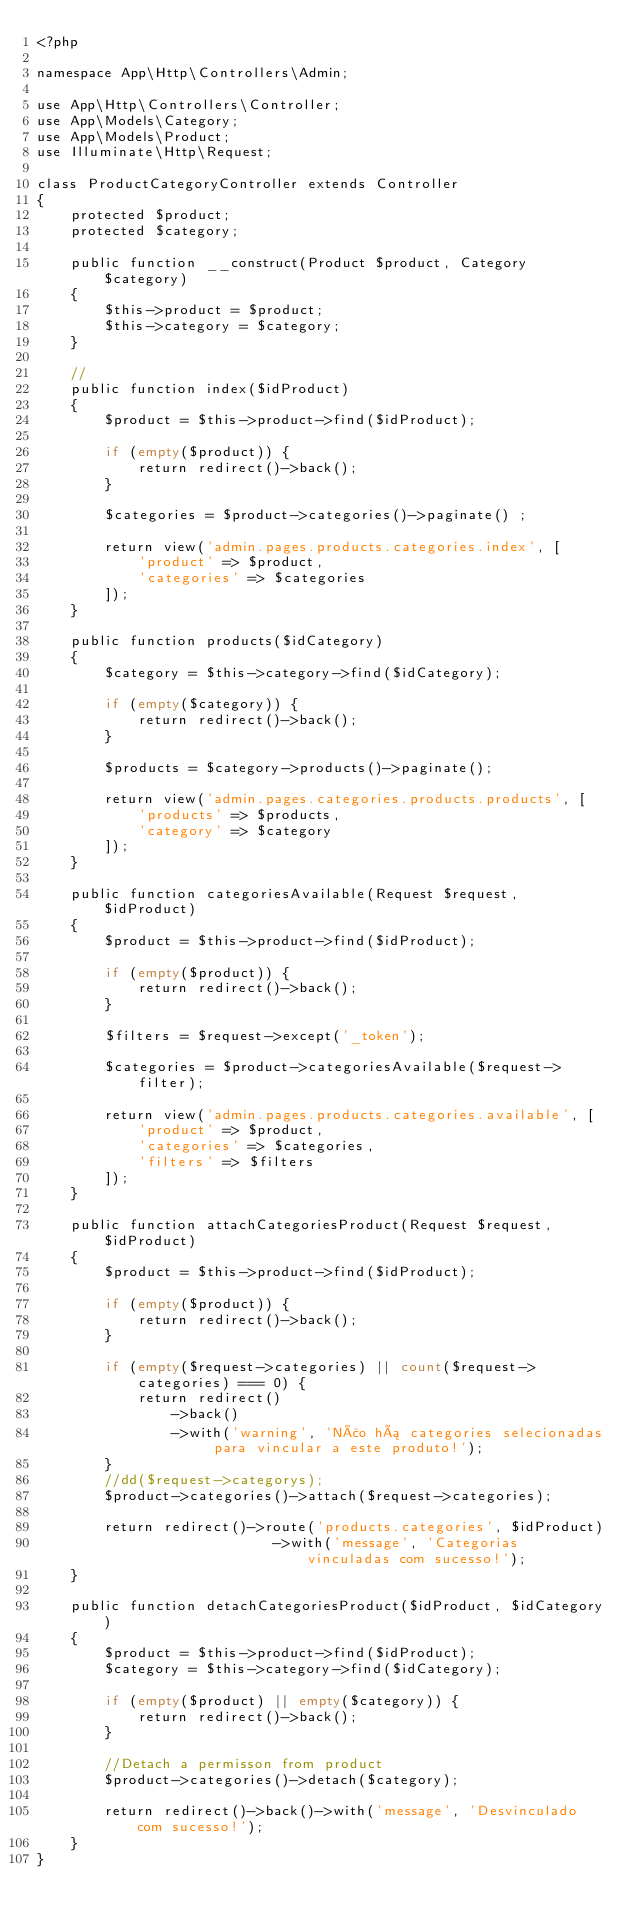<code> <loc_0><loc_0><loc_500><loc_500><_PHP_><?php

namespace App\Http\Controllers\Admin;

use App\Http\Controllers\Controller;
use App\Models\Category;
use App\Models\Product;
use Illuminate\Http\Request;

class ProductCategoryController extends Controller
{
    protected $product;
    protected $category;

    public function __construct(Product $product, Category $category)
    {
        $this->product = $product;
        $this->category = $category;
    }

    //
    public function index($idProduct)
    {
        $product = $this->product->find($idProduct);

        if (empty($product)) {
            return redirect()->back();
        }

        $categories = $product->categories()->paginate() ;

        return view('admin.pages.products.categories.index', [
            'product' => $product,
            'categories' => $categories
        ]);
    }

    public function products($idCategory)
    {
        $category = $this->category->find($idCategory);

        if (empty($category)) {
            return redirect()->back();
        }

        $products = $category->products()->paginate();

        return view('admin.pages.categories.products.products', [
            'products' => $products,
            'category' => $category
        ]);
    }

    public function categoriesAvailable(Request $request, $idProduct)
    {
        $product = $this->product->find($idProduct);

        if (empty($product)) {
            return redirect()->back();
        }

        $filters = $request->except('_token');

        $categories = $product->categoriesAvailable($request->filter);

        return view('admin.pages.products.categories.available', [
            'product' => $product,
            'categories' => $categories,
            'filters' => $filters
        ]);
    }

    public function attachCategoriesProduct(Request $request, $idProduct)
    {
        $product = $this->product->find($idProduct);

        if (empty($product)) {
            return redirect()->back();
        }

        if (empty($request->categories) || count($request->categories) === 0) {
            return redirect()
                ->back()
                ->with('warning', 'Não há categories selecionadas para vincular a este produto!');
        }
        //dd($request->categorys);
        $product->categories()->attach($request->categories);

        return redirect()->route('products.categories', $idProduct)
                            ->with('message', 'Categorias vinculadas com sucesso!');
    }

    public function detachCategoriesProduct($idProduct, $idCategory)
    {
        $product = $this->product->find($idProduct);
        $category = $this->category->find($idCategory);

        if (empty($product) || empty($category)) {
            return redirect()->back();
        }

        //Detach a permisson from product
        $product->categories()->detach($category);

        return redirect()->back()->with('message', 'Desvinculado com sucesso!');
    }
}
</code> 